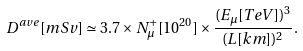<formula> <loc_0><loc_0><loc_500><loc_500>D ^ { a v e } [ m S v ] \simeq 3 . 7 \times N ^ { + } _ { \mu } [ 1 0 ^ { 2 0 } ] \times \frac { ( E _ { \mu } [ T e V ] ) ^ { 3 } } { ( L [ k m ] ) ^ { 2 } } .</formula> 